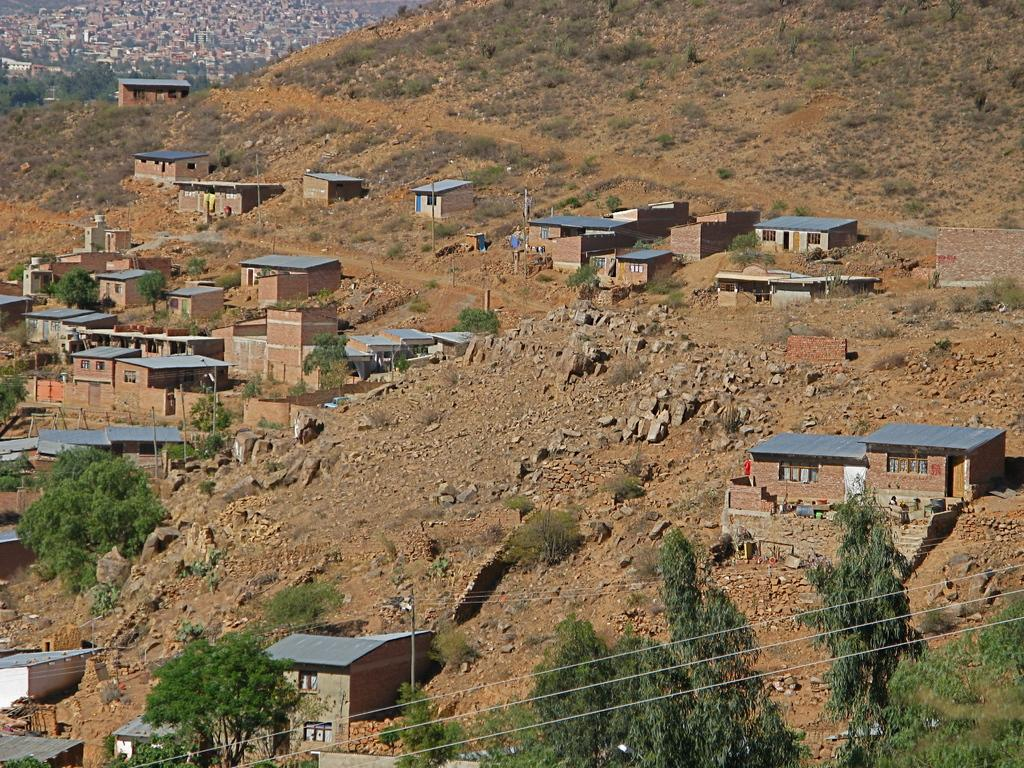What type of structures can be seen in the image? There are many houses in the image. What natural elements are present in the image? There are rocks and trees in the image. What man-made object can be seen in the image? There is an electric pole with wires in the image. What type of stone is being used to build the houses in the image? There is no specific type of stone mentioned or visible in the image; it only shows the houses. What is the temper of the people living in the houses in the image? There is no information about the temper of the people living in the houses in the image. 